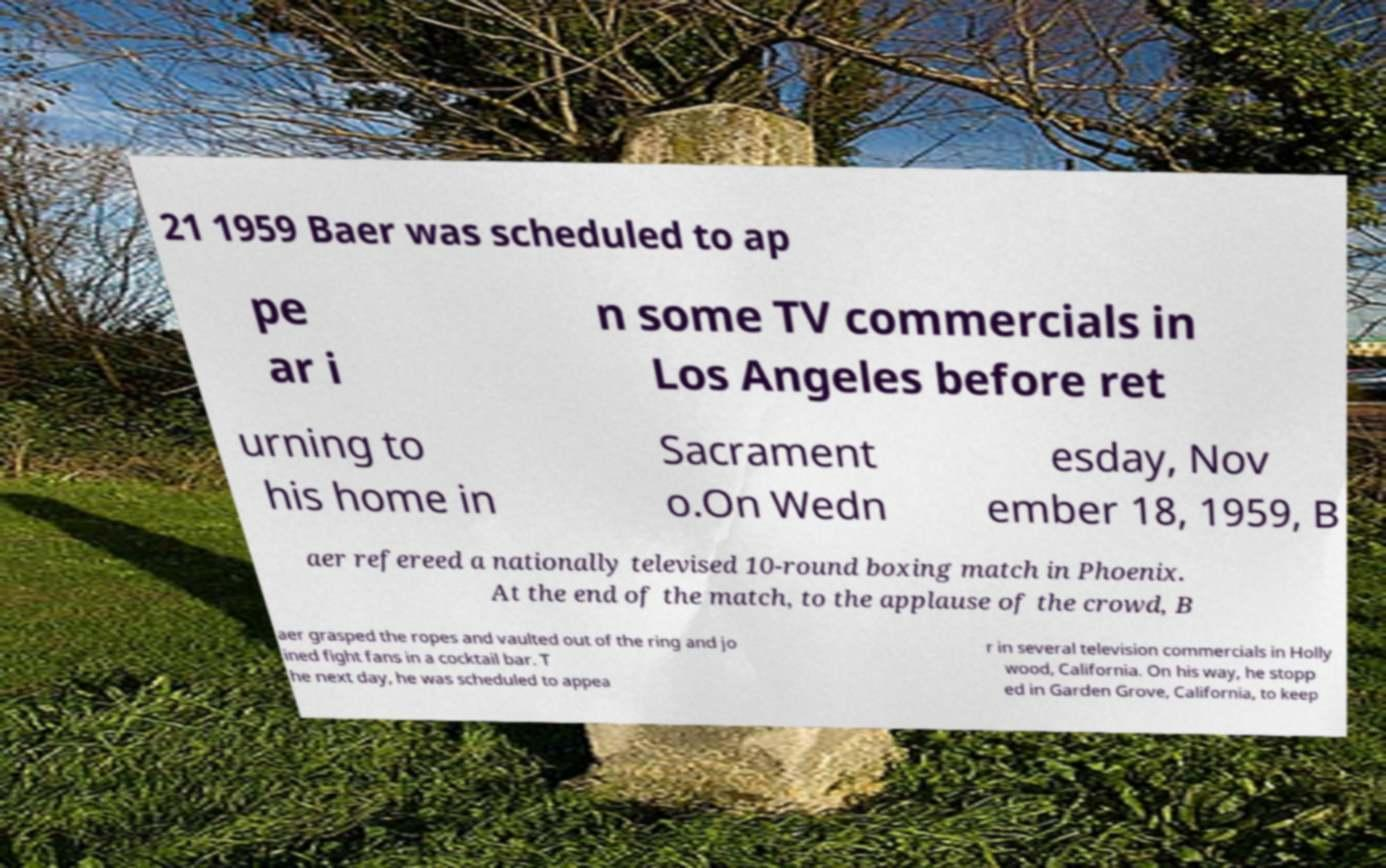What messages or text are displayed in this image? I need them in a readable, typed format. 21 1959 Baer was scheduled to ap pe ar i n some TV commercials in Los Angeles before ret urning to his home in Sacrament o.On Wedn esday, Nov ember 18, 1959, B aer refereed a nationally televised 10-round boxing match in Phoenix. At the end of the match, to the applause of the crowd, B aer grasped the ropes and vaulted out of the ring and jo ined fight fans in a cocktail bar. T he next day, he was scheduled to appea r in several television commercials in Holly wood, California. On his way, he stopp ed in Garden Grove, California, to keep 